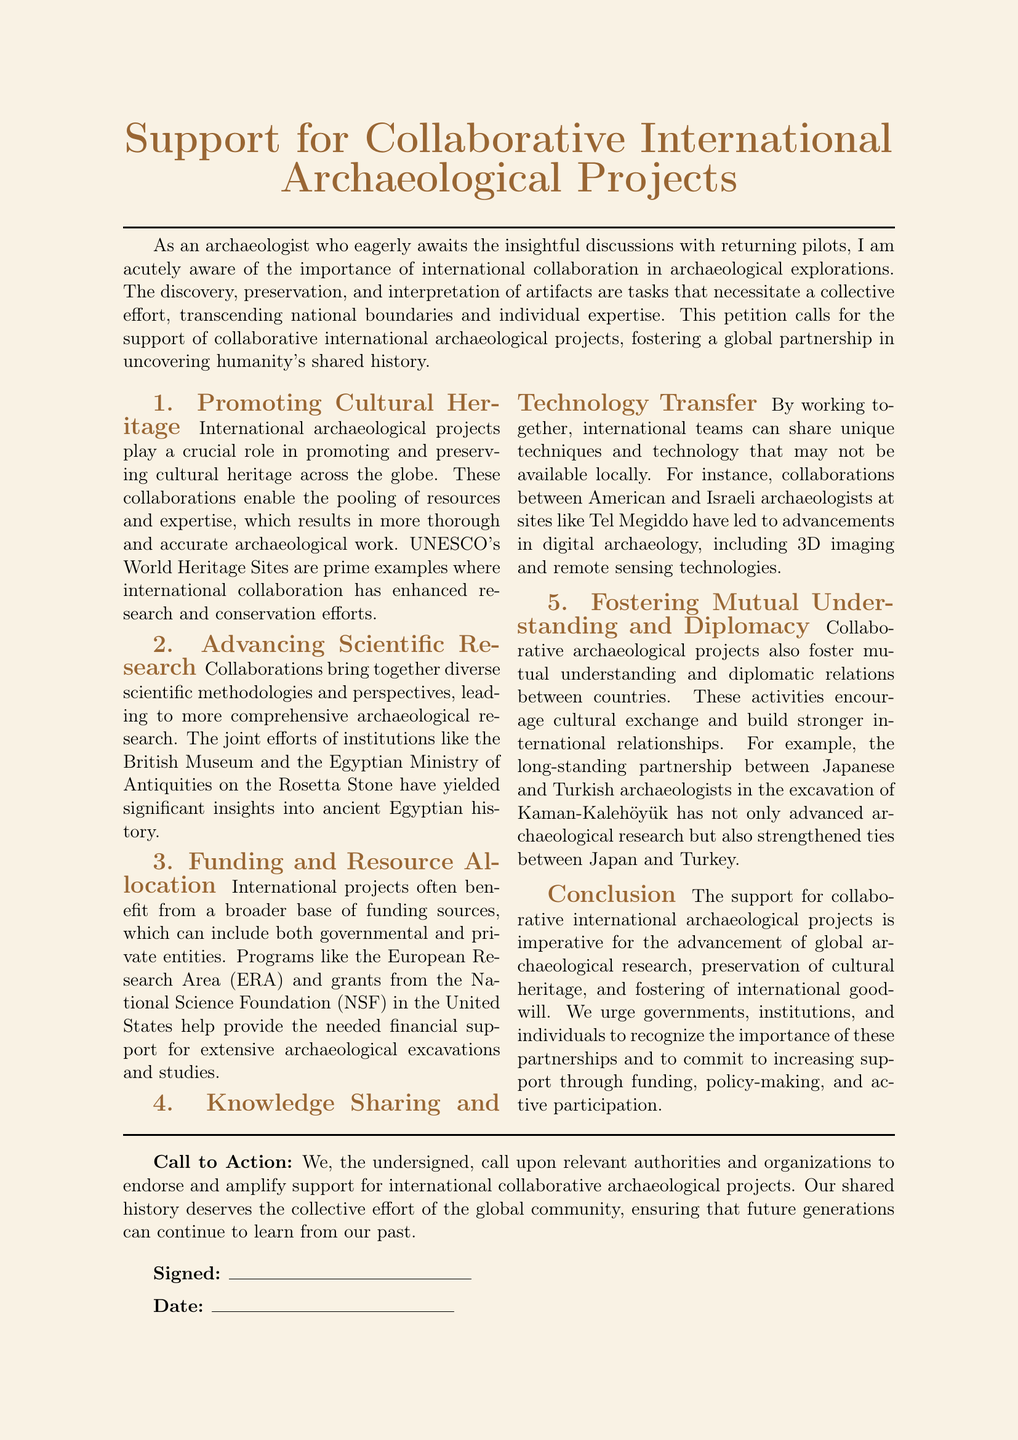What is the title of the petition? The title of the petition is explicitly stated at the beginning of the document.
Answer: Support for Collaborative International Archaeological Projects How many sections are there in the document? The document has five distinct sections that address different aspects of the petition.
Answer: 5 Which organizations are mentioned as examples of collaboration? Specific organizations are provided as examples of international collaborations in archaeological work within the document.
Answer: British Museum and Egyptian Ministry of Antiquities What type of funding sources are mentioned? The document specifies various types of funding sources for international archaeological projects.
Answer: Governmental and private entities What is emphasized as a benefit of international archaeological projects? The document highlights a specific key benefit of international projects in archaeological research.
Answer: Cultural heritage What is the call to action in the document? The document concludes with a specific demand directed at authorities and organizations regarding support.
Answer: Endorse and amplify support Who signed the petition? The section at the bottom provides a place for individuals to sign, but does not specify names.
Answer: The undersigned What year is the date for signing left blank for? The document provides a line for dating the signing but does not specify a year.
Answer: Not specified 